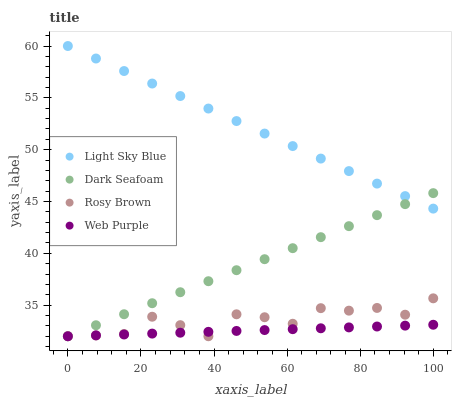Does Web Purple have the minimum area under the curve?
Answer yes or no. Yes. Does Light Sky Blue have the maximum area under the curve?
Answer yes or no. Yes. Does Light Sky Blue have the minimum area under the curve?
Answer yes or no. No. Does Web Purple have the maximum area under the curve?
Answer yes or no. No. Is Light Sky Blue the smoothest?
Answer yes or no. Yes. Is Rosy Brown the roughest?
Answer yes or no. Yes. Is Web Purple the smoothest?
Answer yes or no. No. Is Web Purple the roughest?
Answer yes or no. No. Does Dark Seafoam have the lowest value?
Answer yes or no. Yes. Does Light Sky Blue have the lowest value?
Answer yes or no. No. Does Light Sky Blue have the highest value?
Answer yes or no. Yes. Does Web Purple have the highest value?
Answer yes or no. No. Is Web Purple less than Light Sky Blue?
Answer yes or no. Yes. Is Light Sky Blue greater than Web Purple?
Answer yes or no. Yes. Does Rosy Brown intersect Web Purple?
Answer yes or no. Yes. Is Rosy Brown less than Web Purple?
Answer yes or no. No. Is Rosy Brown greater than Web Purple?
Answer yes or no. No. Does Web Purple intersect Light Sky Blue?
Answer yes or no. No. 